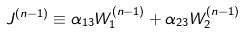Convert formula to latex. <formula><loc_0><loc_0><loc_500><loc_500>J ^ { ( n - 1 ) } \equiv \alpha _ { 1 3 } W _ { 1 } ^ { ( n - 1 ) } + \alpha _ { 2 3 } W _ { 2 } ^ { ( n - 1 ) }</formula> 